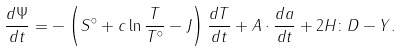Convert formula to latex. <formula><loc_0><loc_0><loc_500><loc_500>\frac { d \Psi } { d t } = - \left ( S ^ { \circ } + c \ln \frac { T } { T ^ { \circ } } - J \right ) \frac { d T } { d t } + { A } \cdot \frac { d { a } } { d t } + 2 { H } \colon { D } - Y .</formula> 